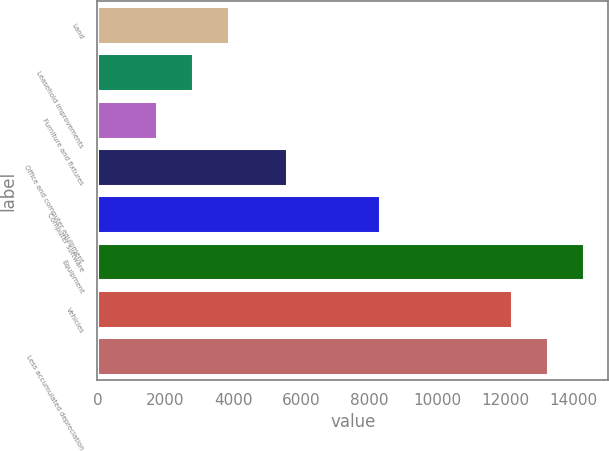Convert chart to OTSL. <chart><loc_0><loc_0><loc_500><loc_500><bar_chart><fcel>Land<fcel>Leasehold improvements<fcel>Furniture and fixtures<fcel>Office and computer equipment<fcel>Computer software<fcel>Equipment<fcel>Vehicles<fcel>Less accumulated depreciation<nl><fcel>3877<fcel>2814.5<fcel>1752<fcel>5585<fcel>8313<fcel>14295<fcel>12170<fcel>13232.5<nl></chart> 